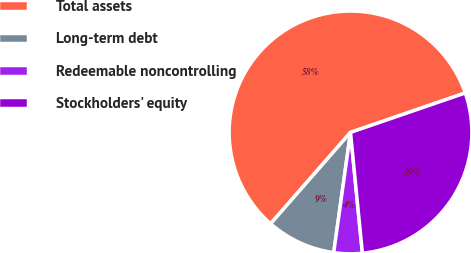Convert chart. <chart><loc_0><loc_0><loc_500><loc_500><pie_chart><fcel>Total assets<fcel>Long-term debt<fcel>Redeemable noncontrolling<fcel>Stockholders' equity<nl><fcel>58.29%<fcel>9.23%<fcel>3.77%<fcel>28.71%<nl></chart> 